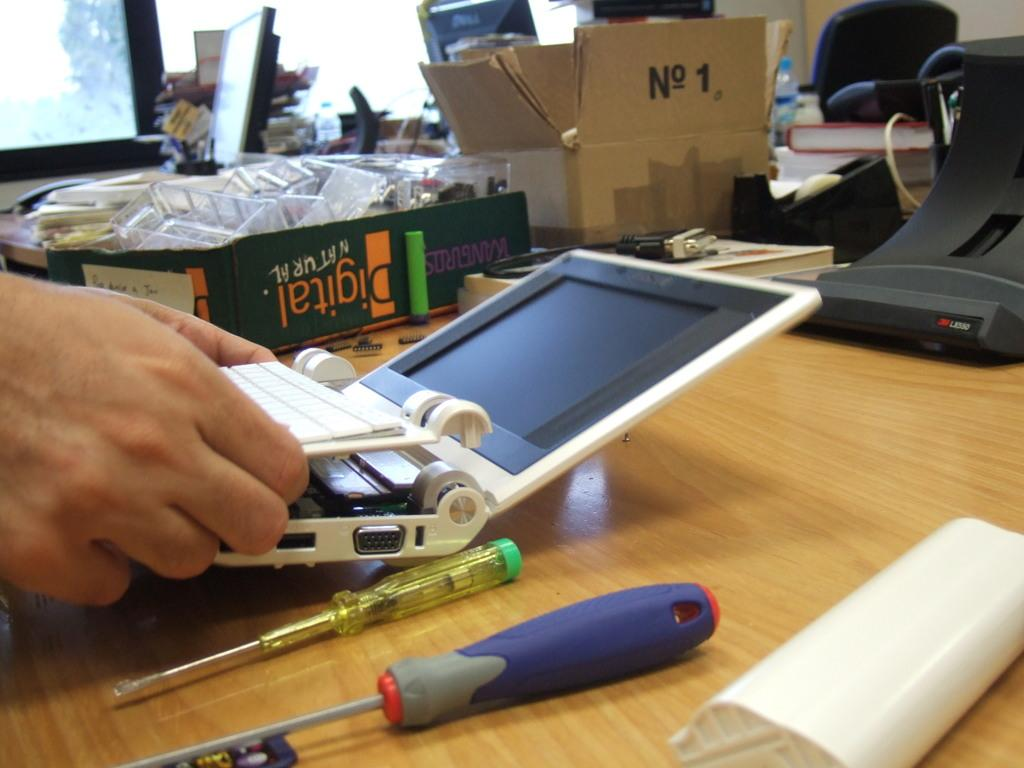<image>
Offer a succinct explanation of the picture presented. A man is working at a desk with a book called Digital Natural on it. 